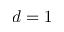<formula> <loc_0><loc_0><loc_500><loc_500>d = 1</formula> 